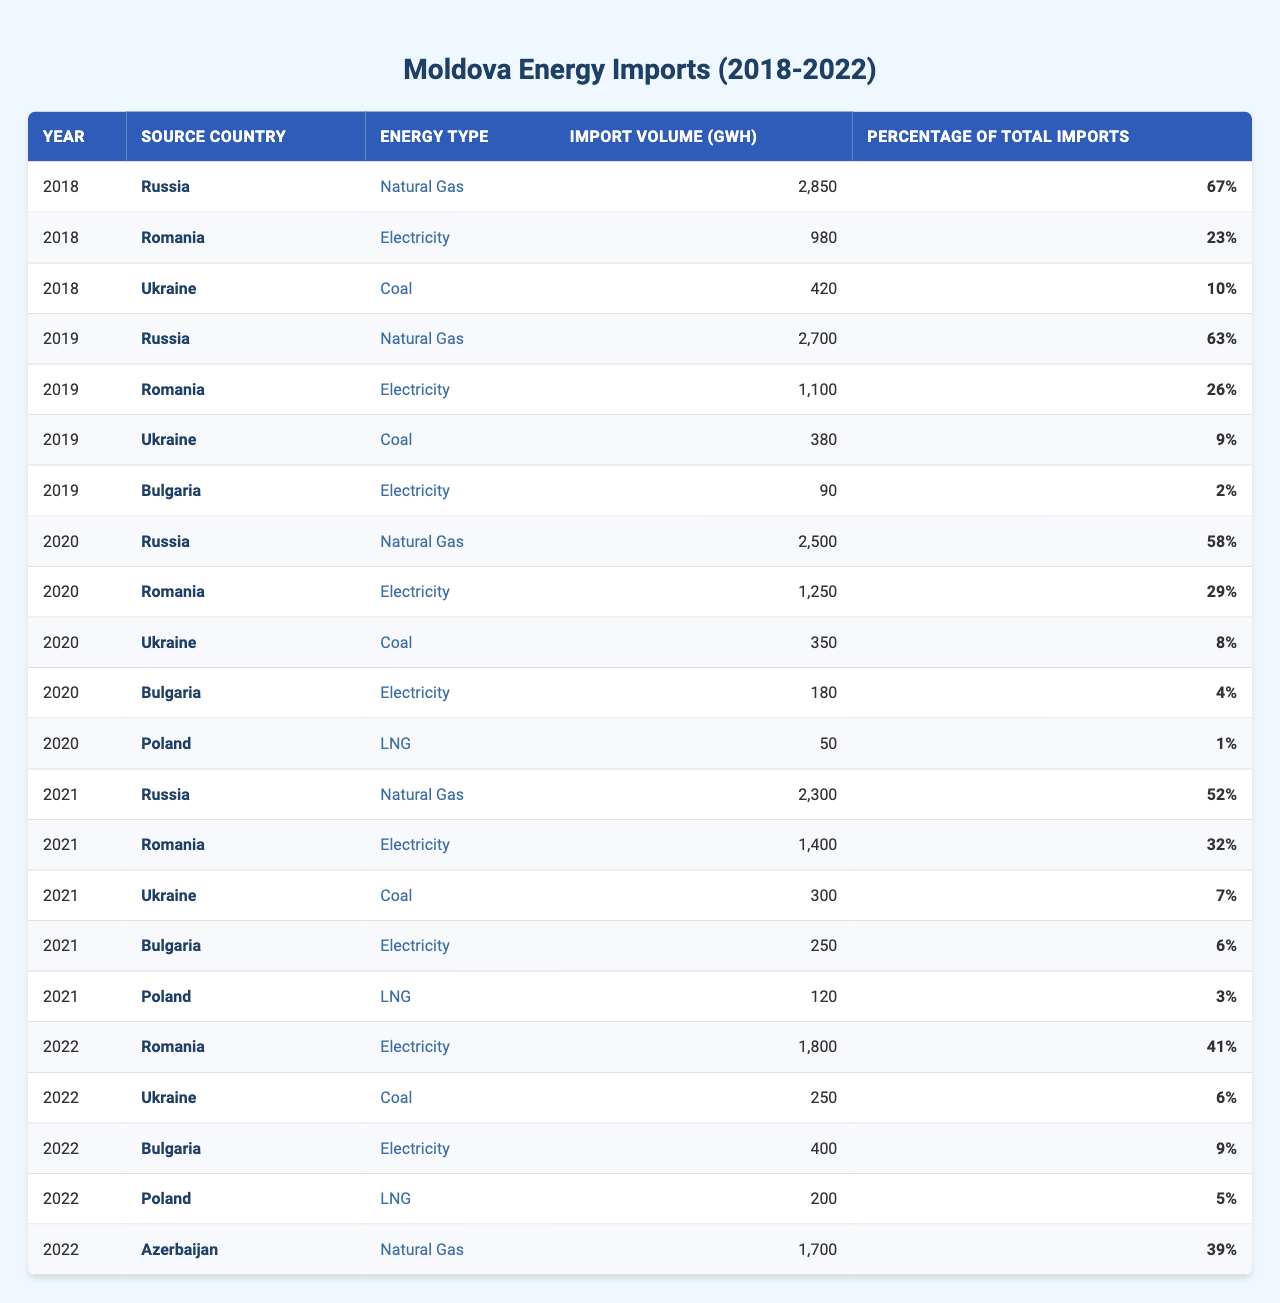What was the total import volume of natural gas from Russia in 2020? In the table, find the row for 2020 and look for Russia under the "Source Country" column and "Natural Gas" under the "Energy Type" column. The import volume listed is 2500 GWh.
Answer: 2500 GWh Which country supplied the largest volume of electricity in 2021? To answer this, review the data for 2021. Compare the import volumes of electricity from Romania, Bulgaria, and any other relevant country. Romania is the highest with 1400 GWh.
Answer: Romania What percentage of total imports in 2018 did Ukrainian coal represent? In 2018, the total imports are from Russia (2850 GWh), Romania (980 GWh), and Ukraine (420 GWh). The percentage of Ukrainian coal is given as 10%, which is already present in the table.
Answer: 10% How did the import volume of electricity from Romania change from 2018 to 2022? Review the table to extract the import volumes for Romania from 2018 (980 GWh), 2019 (1100 GWh), 2020 (1250 GWh), 2021 (1400 GWh), and 2022 (1800 GWh). The change from 2018 to 2022 is an increase of 820 GWh.
Answer: Increased by 820 GWh Was there a year in which Moldova imported more than 3000 GWh of energy overall? To find this, sum the total import volumes for each year. In 2018, the total is 2850 GWh + 980 GWh + 420 GWh = 4250 GWh; similarly for other years. None of the years show a volume over 3000 GWh in total.
Answer: No Which energy source had the lowest import percentage in 2020 and what was that percentage? Look across the data for 2020 and identify all sources and their respective percentages. The lowest is LNG from Poland, which represented 1% of total imports.
Answer: 1% What was the average import volume of natural gas from 2018 to 2022? Gather the volumes of natural gas for 2018 (2850 GWh), 2019 (2700 GWh), 2020 (2500 GWh), 2021 (2300 GWh), and 2022 (1700 GWh), then calculate the average by summing these values and dividing by the number of years: (2850 + 2700 + 2500 + 2300 + 1700) / 5 = 2510 GWh.
Answer: 2510 GWh In which year did Moldova first import LNG and from which country? Review the table to see that LNG was first imported in 2020 from Poland, where the import volume was 50 GWh listed under energy type.
Answer: 2020, Poland Compare the total import volume from Russia in 2021 with the total from Romania over all years. Sum the import volumes from Russia in 2021 (2300 GWh) and total the imports from Romania across years (980 + 1100 + 1250 + 1400 + 1800 = 5530 GWh). Russia's figure is less than Romania's total imports.
Answer: Russia's volume is lower 